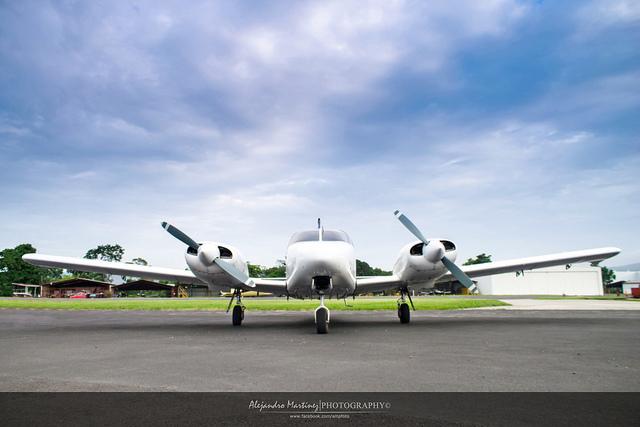Is the plane facing away from the camera?
Answer briefly. No. What kind of plane is this?
Concise answer only. Propeller. How many hangars do you see?
Give a very brief answer. 1. 